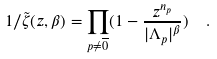Convert formula to latex. <formula><loc_0><loc_0><loc_500><loc_500>1 / \tilde { \zeta } ( z , \beta ) = \prod _ { p \neq \overline { 0 } } ( 1 - \frac { z ^ { n _ { p } } } { | \Lambda _ { p } | ^ { \beta } } ) \ \ .</formula> 